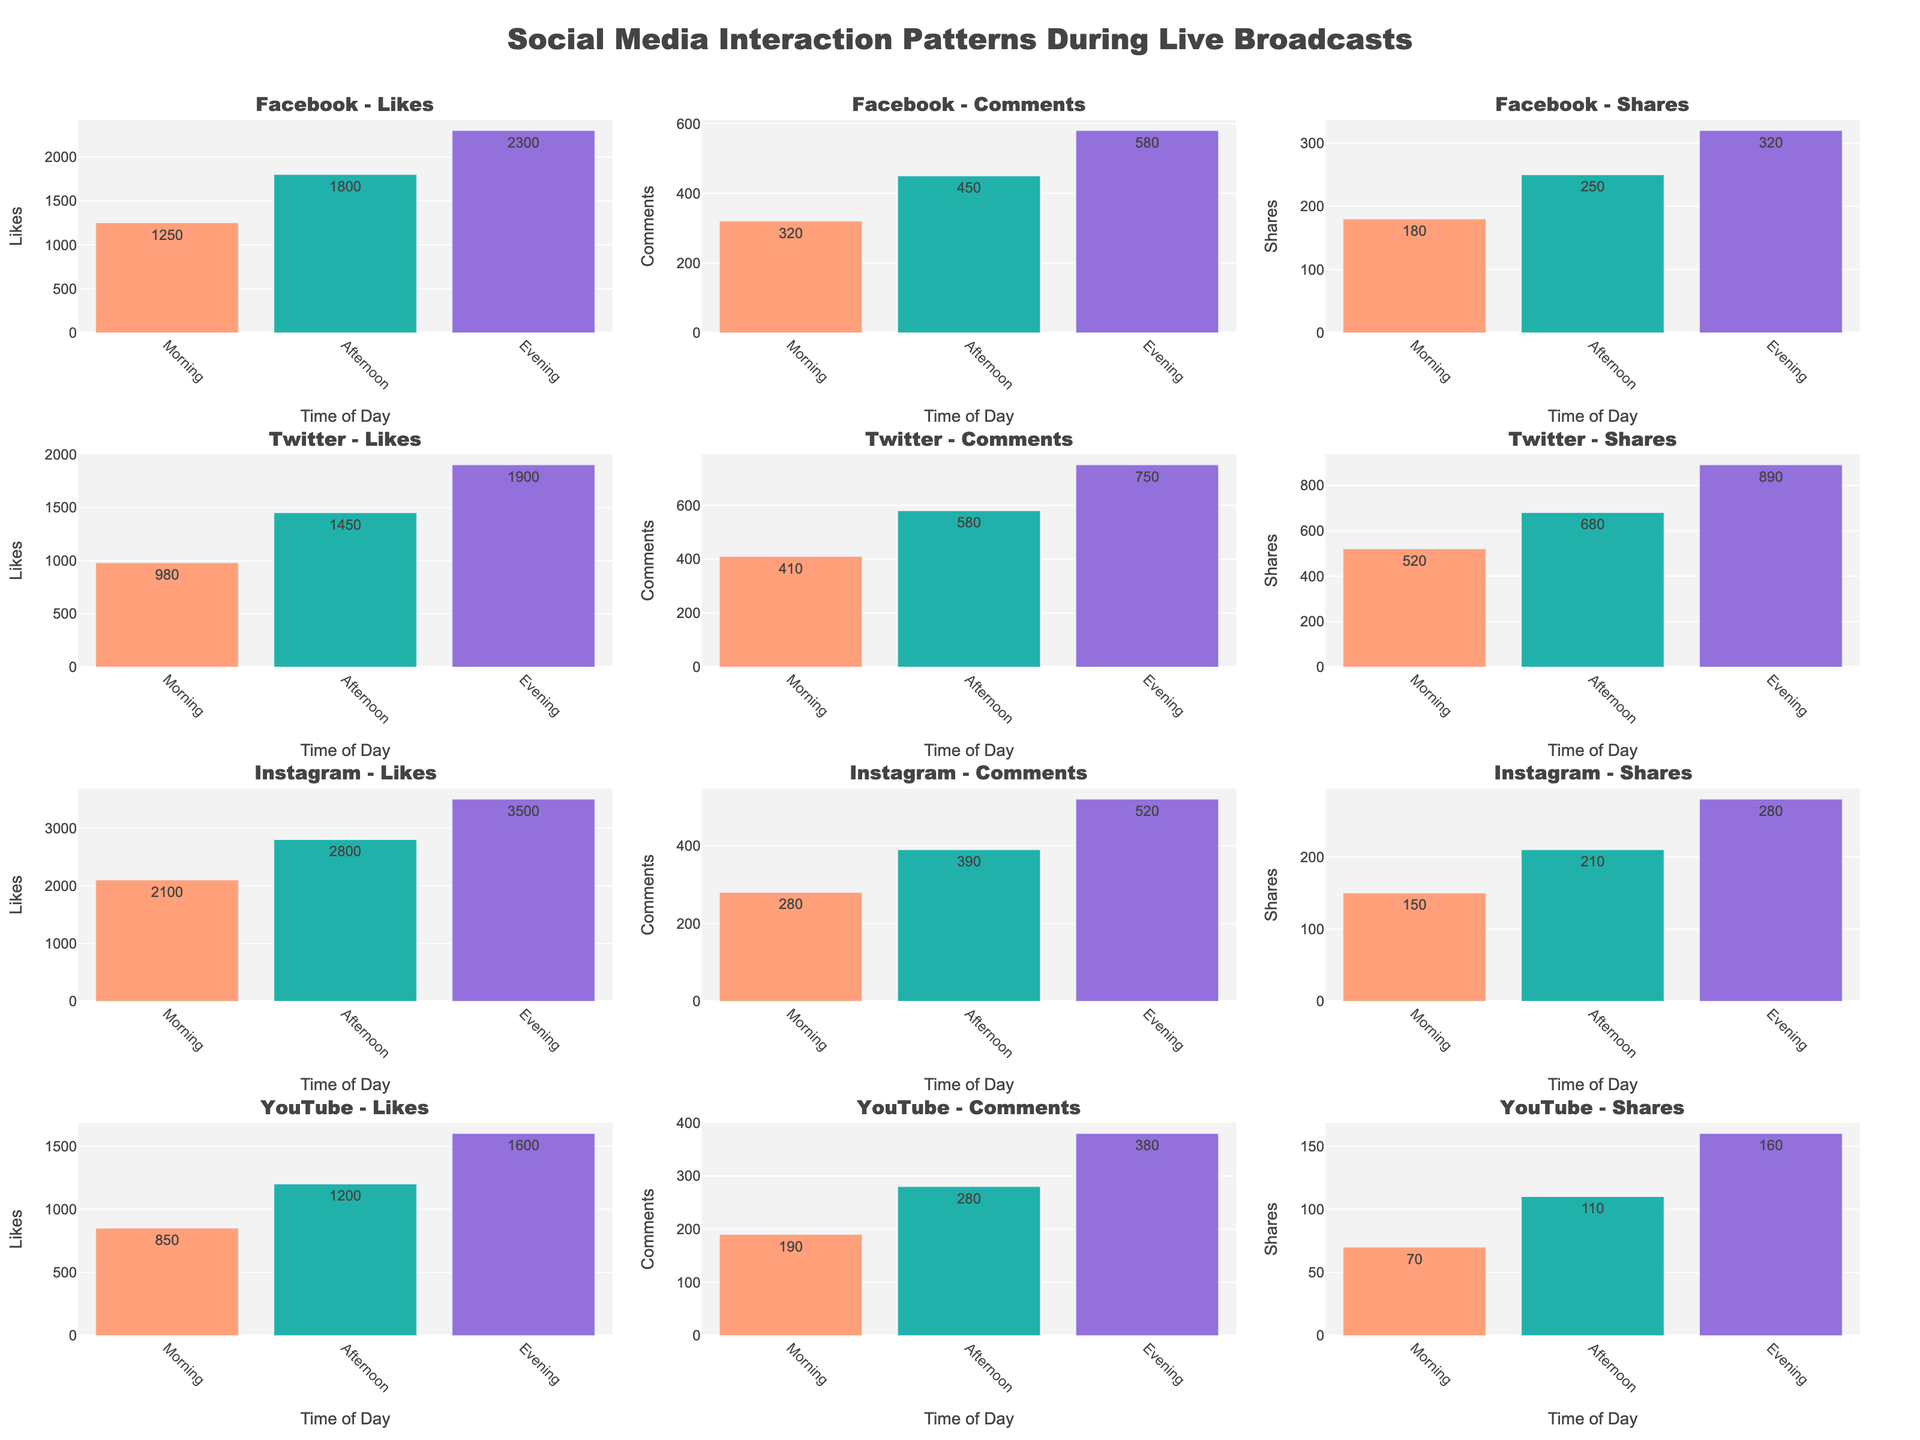What does the title of the figure represent? The title is located at the top center of the figure. It reads "Social Media Interaction Patterns During Live Broadcasts" which provides an overview of what the entire data set represents.
Answer: Social Media Interaction Patterns During Live Broadcasts Which platform had the highest number of likes during the evening? To find this, look at the 'Likes' subplot for each platform in the evening section of the x-axis. Compare the values visually.
Answer: Instagram How do the number of comments on Facebook compare between morning and evening? Look at the "Facebook - Comments" subplot. Compare the height of the bars for morning and evening. The comments are higher in the evening.
Answer: More in the evening What is the sum of shares on Twitter during all three times of day? Add the three values from the "Twitter - Shares" subplot. 520 (Morning) + 680 (Afternoon) + 890 (Evening) = 2090.
Answer: 2090 Which time of day saw the lowest engagement (likes, comments, and shares combined) on YouTube? Check the YouTube plots for Likes, Comments, and Shares. Sum the values for each time of day (Morning: 850 + 190 + 70, Afternoon: 1200 + 280 + 110, Evening: 1600 + 380 + 160).
Answer: Morning Are the evening likes on Facebook higher or lower than the afternoon likes on Instagram? Compare the bar representing evening likes on Facebook to the bar representing afternoon likes on Instagram. The latter value is 2800 while the former is 2300.
Answer: Lower Which platform has the smallest difference between morning and afternoon shares? Calculate the difference in shares for morning and afternoon for each platform:
- Facebook (250 - 180 = 70)
- Twitter (680 - 520 = 160)
- Instagram (210 - 150 = 60)
- YouTube (110 - 70 = 40). 
The smallest difference is for YouTube.
Answer: YouTube What is the most interacted time of day across all platforms when considering all three metrics? Identify the time of day with the highest total interaction sum for all platforms by checking the heights of the bars for likes, comments, and shares. Evening generally shows highest values across more platforms.
Answer: Evening 